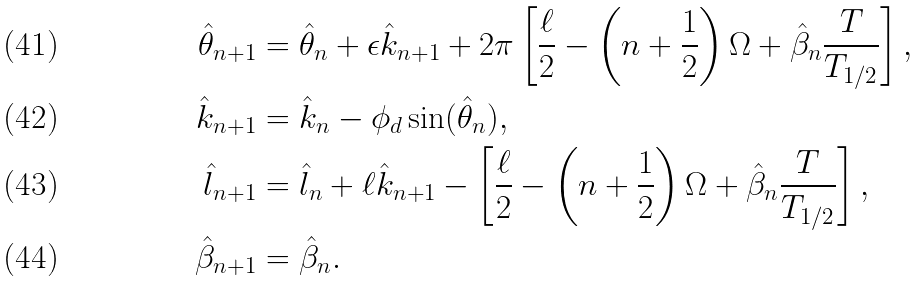Convert formula to latex. <formula><loc_0><loc_0><loc_500><loc_500>\hat { \theta } _ { n + 1 } & = \hat { \theta } _ { n } + \epsilon \hat { k } _ { n + 1 } + 2 \pi \left [ \frac { \ell } { 2 } - \left ( n + \frac { 1 } { 2 } \right ) \Omega + \hat { \beta } _ { n } \frac { T } { T _ { 1 / 2 } } \right ] , \\ \hat { k } _ { n + 1 } & = \hat { k } _ { n } - \phi _ { d } \sin ( \hat { \theta } _ { n } ) , \\ \hat { l } _ { n + 1 } & = \hat { l } _ { n } + \ell \hat { k } _ { n + 1 } - \left [ \frac { \ell } { 2 } - \left ( n + \frac { 1 } { 2 } \right ) \Omega + \hat { \beta } _ { n } \frac { T } { T _ { 1 / 2 } } \right ] , \\ \hat { \beta } _ { n + 1 } & = \hat { \beta } _ { n } .</formula> 